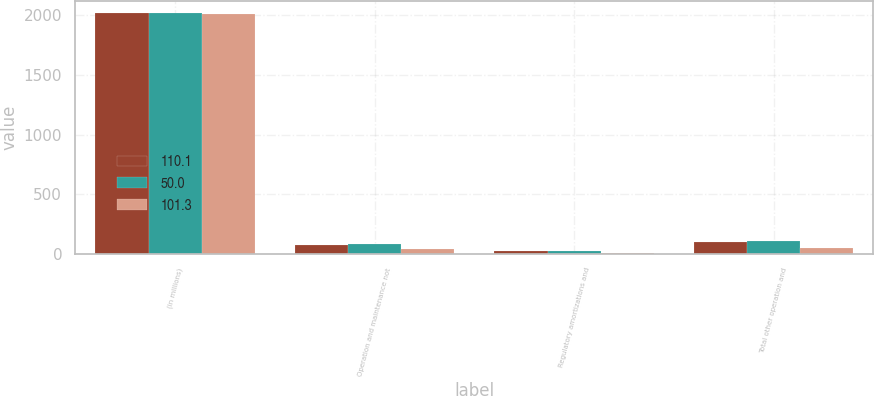Convert chart to OTSL. <chart><loc_0><loc_0><loc_500><loc_500><stacked_bar_chart><ecel><fcel>(in millions)<fcel>Operation and maintenance not<fcel>Regulatory amortizations and<fcel>Total other operation and<nl><fcel>110.1<fcel>2017<fcel>78.3<fcel>23<fcel>101.3<nl><fcel>50<fcel>2016<fcel>86.4<fcel>23.6<fcel>110.1<nl><fcel>101.3<fcel>2015<fcel>43.2<fcel>6.7<fcel>50<nl></chart> 